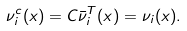Convert formula to latex. <formula><loc_0><loc_0><loc_500><loc_500>\nu ^ { c } _ { i } ( x ) = C \bar { \nu } ^ { T } _ { i } ( x ) = \nu _ { i } ( x ) .</formula> 